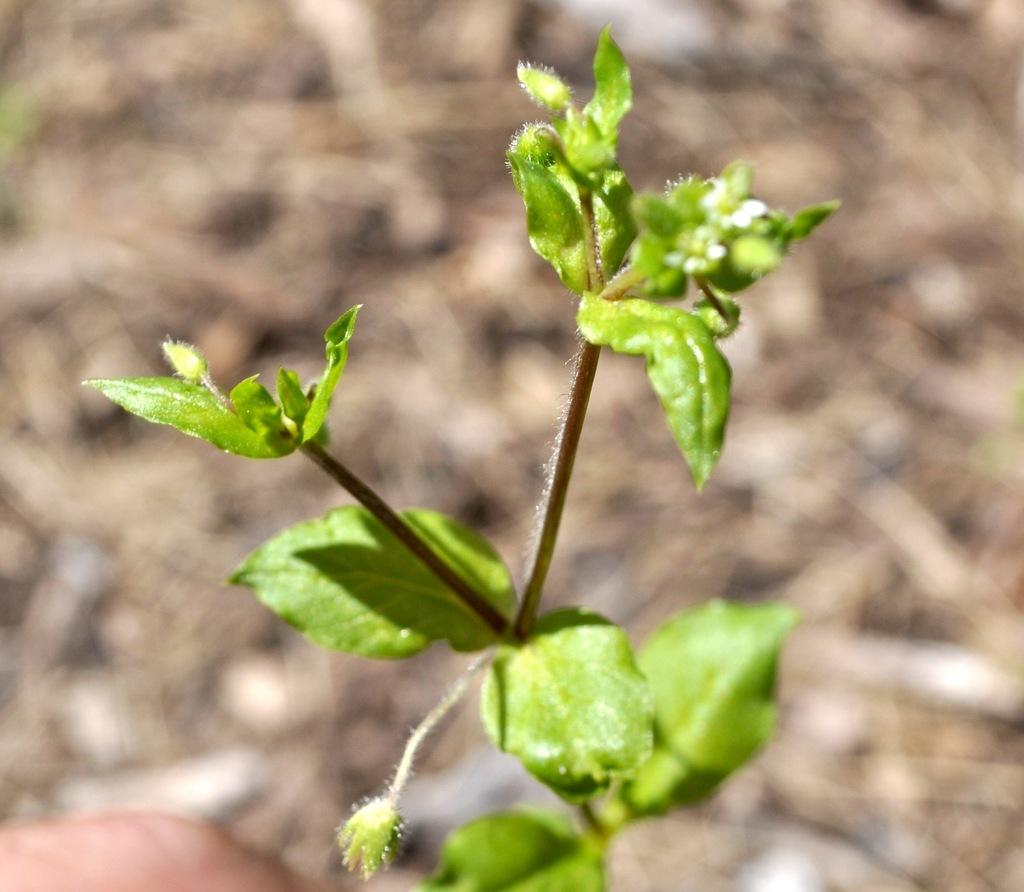What is present in the image? There is a plant in the image. What can be observed about the plant's leaves? The plant has green leaves. Where is the girl holding the cup and boot in the image? There is no girl, cup, or boot present in the image; it only features a plant with green leaves. 